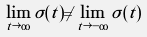Convert formula to latex. <formula><loc_0><loc_0><loc_500><loc_500>\lim _ { t \rightarrow \infty } \sigma ( t ) \neq \lim _ { t \rightarrow - \infty } \sigma ( t )</formula> 